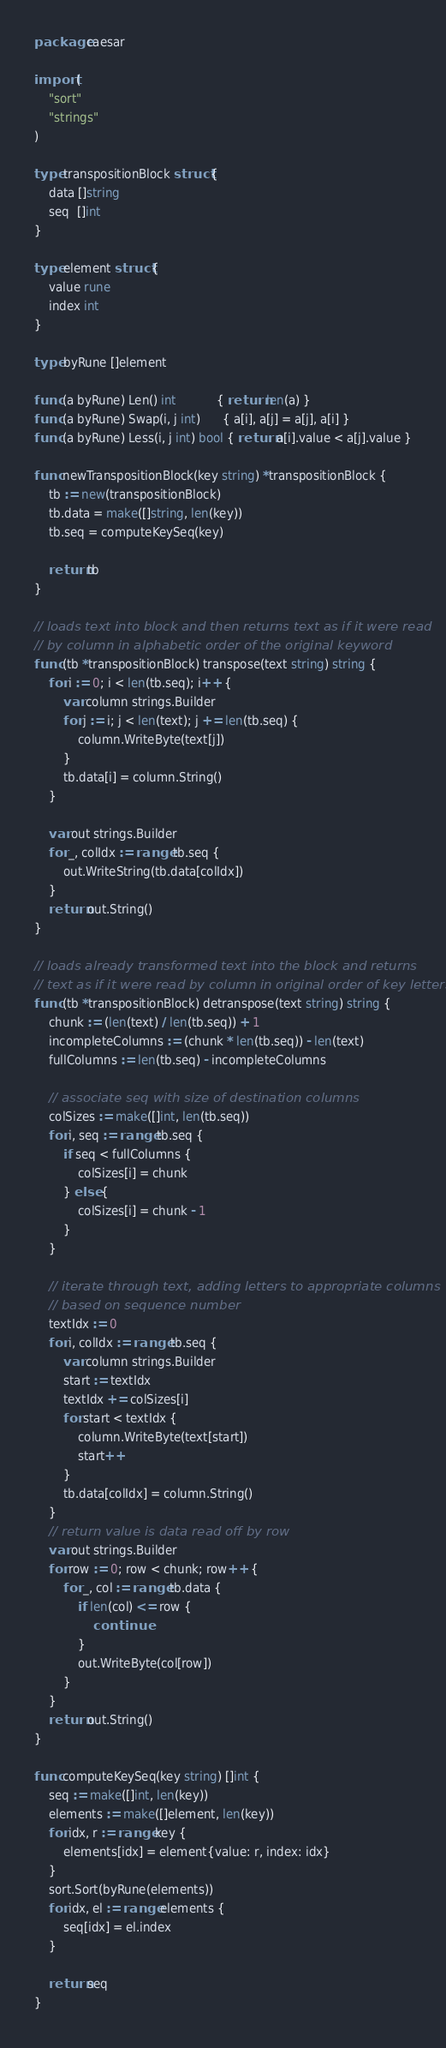<code> <loc_0><loc_0><loc_500><loc_500><_Go_>package caesar

import (
	"sort"
	"strings"
)

type transpositionBlock struct {
	data []string
	seq  []int
}

type element struct {
	value rune
	index int
}

type byRune []element

func (a byRune) Len() int           { return len(a) }
func (a byRune) Swap(i, j int)      { a[i], a[j] = a[j], a[i] }
func (a byRune) Less(i, j int) bool { return a[i].value < a[j].value }

func newTranspositionBlock(key string) *transpositionBlock {
	tb := new(transpositionBlock)
	tb.data = make([]string, len(key))
	tb.seq = computeKeySeq(key)

	return tb
}

// loads text into block and then returns text as if it were read
// by column in alphabetic order of the original keyword
func (tb *transpositionBlock) transpose(text string) string {
	for i := 0; i < len(tb.seq); i++ {
		var column strings.Builder
		for j := i; j < len(text); j += len(tb.seq) {
			column.WriteByte(text[j])
		}
		tb.data[i] = column.String()
	}

	var out strings.Builder
	for _, colIdx := range tb.seq {
		out.WriteString(tb.data[colIdx])
	}
	return out.String()
}

// loads already transformed text into the block and returns
// text as if it were read by column in original order of key letters
func (tb *transpositionBlock) detranspose(text string) string {
	chunk := (len(text) / len(tb.seq)) + 1
	incompleteColumns := (chunk * len(tb.seq)) - len(text)
	fullColumns := len(tb.seq) - incompleteColumns

	// associate seq with size of destination columns
	colSizes := make([]int, len(tb.seq))
	for i, seq := range tb.seq {
		if seq < fullColumns {
			colSizes[i] = chunk
		} else {
			colSizes[i] = chunk - 1
		}
	}

	// iterate through text, adding letters to appropriate columns
	// based on sequence number
	textIdx := 0
	for i, colIdx := range tb.seq {
		var column strings.Builder
		start := textIdx
		textIdx += colSizes[i]
		for start < textIdx {
			column.WriteByte(text[start])
			start++
		}
		tb.data[colIdx] = column.String()
	}
	// return value is data read off by row
	var out strings.Builder
	for row := 0; row < chunk; row++ {
		for _, col := range tb.data {
			if len(col) <= row {
				continue
			}
			out.WriteByte(col[row])
		}
	}
	return out.String()
}

func computeKeySeq(key string) []int {
	seq := make([]int, len(key))
	elements := make([]element, len(key))
	for idx, r := range key {
		elements[idx] = element{value: r, index: idx}
	}
	sort.Sort(byRune(elements))
	for idx, el := range elements {
		seq[idx] = el.index
	}

	return seq
}
</code> 